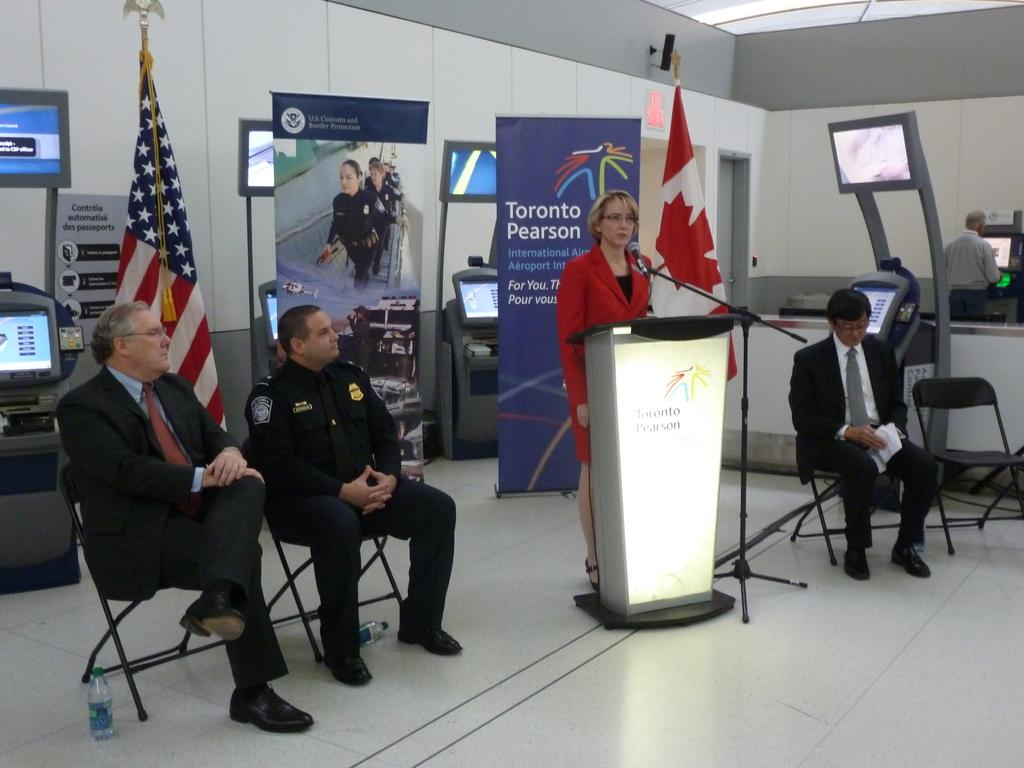<image>
Offer a succinct explanation of the picture presented. A woman is at a podium that says Toronto Pearson. 